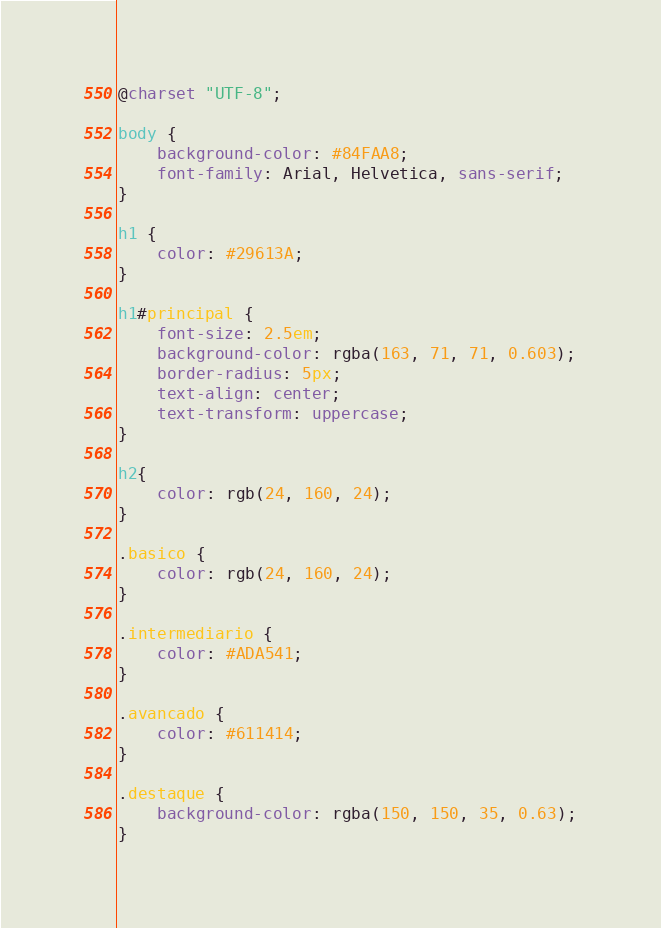Convert code to text. <code><loc_0><loc_0><loc_500><loc_500><_CSS_>@charset "UTF-8";

body {
    background-color: #84FAA8;
    font-family: Arial, Helvetica, sans-serif;
}

h1 {
    color: #29613A;
}

h1#principal {
    font-size: 2.5em;
    background-color: rgba(163, 71, 71, 0.603);
    border-radius: 5px;
    text-align: center;
    text-transform: uppercase;
}

h2{
    color: rgb(24, 160, 24);
}

.basico {
    color: rgb(24, 160, 24);
}

.intermediario {
    color: #ADA541;
}

.avancado {
    color: #611414;
}

.destaque {
    background-color: rgba(150, 150, 35, 0.63);
}</code> 